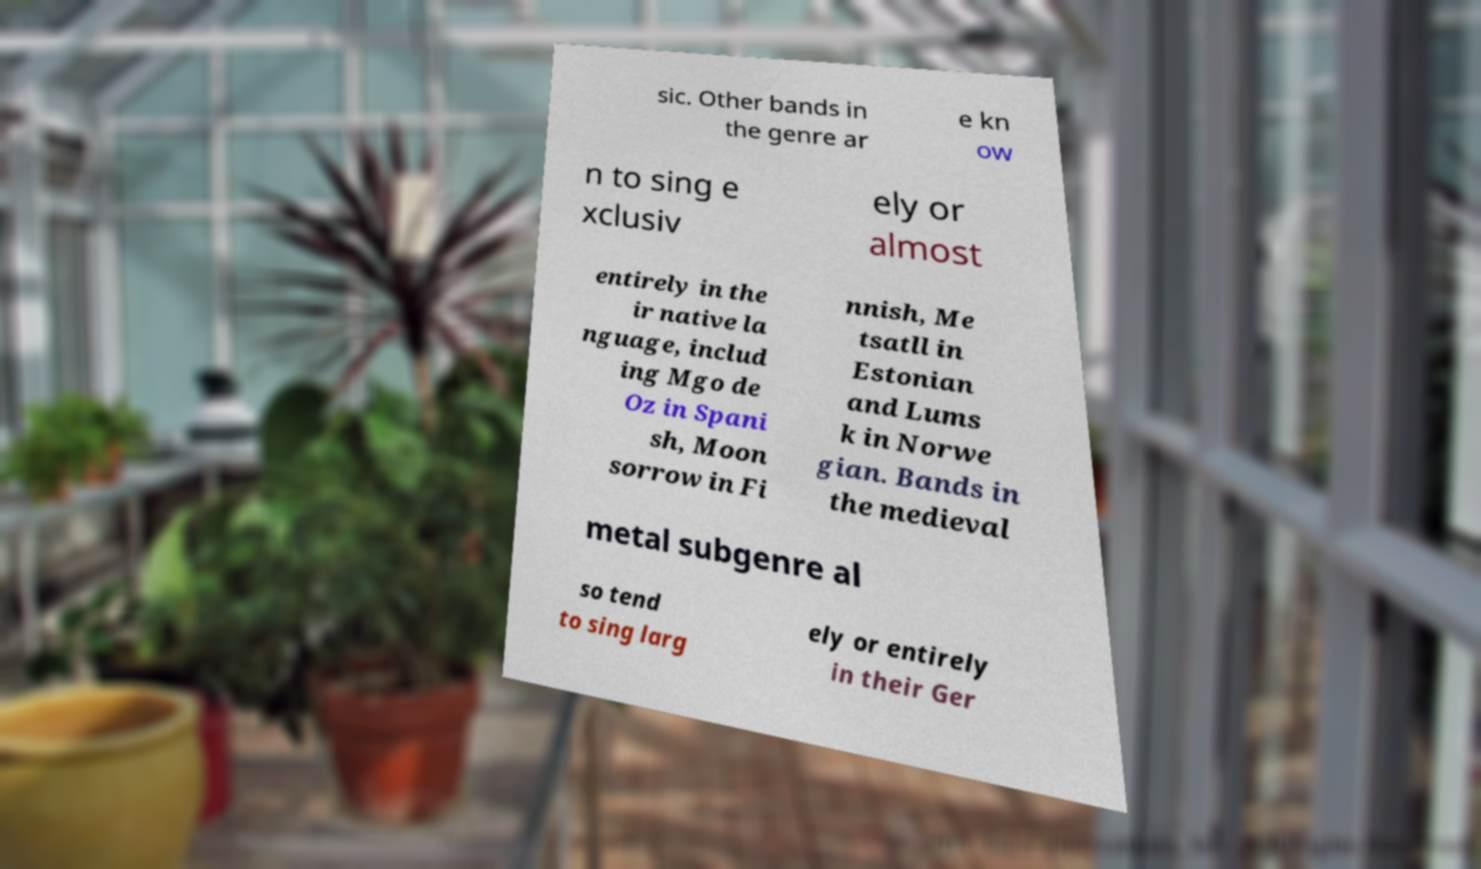For documentation purposes, I need the text within this image transcribed. Could you provide that? sic. Other bands in the genre ar e kn ow n to sing e xclusiv ely or almost entirely in the ir native la nguage, includ ing Mgo de Oz in Spani sh, Moon sorrow in Fi nnish, Me tsatll in Estonian and Lums k in Norwe gian. Bands in the medieval metal subgenre al so tend to sing larg ely or entirely in their Ger 